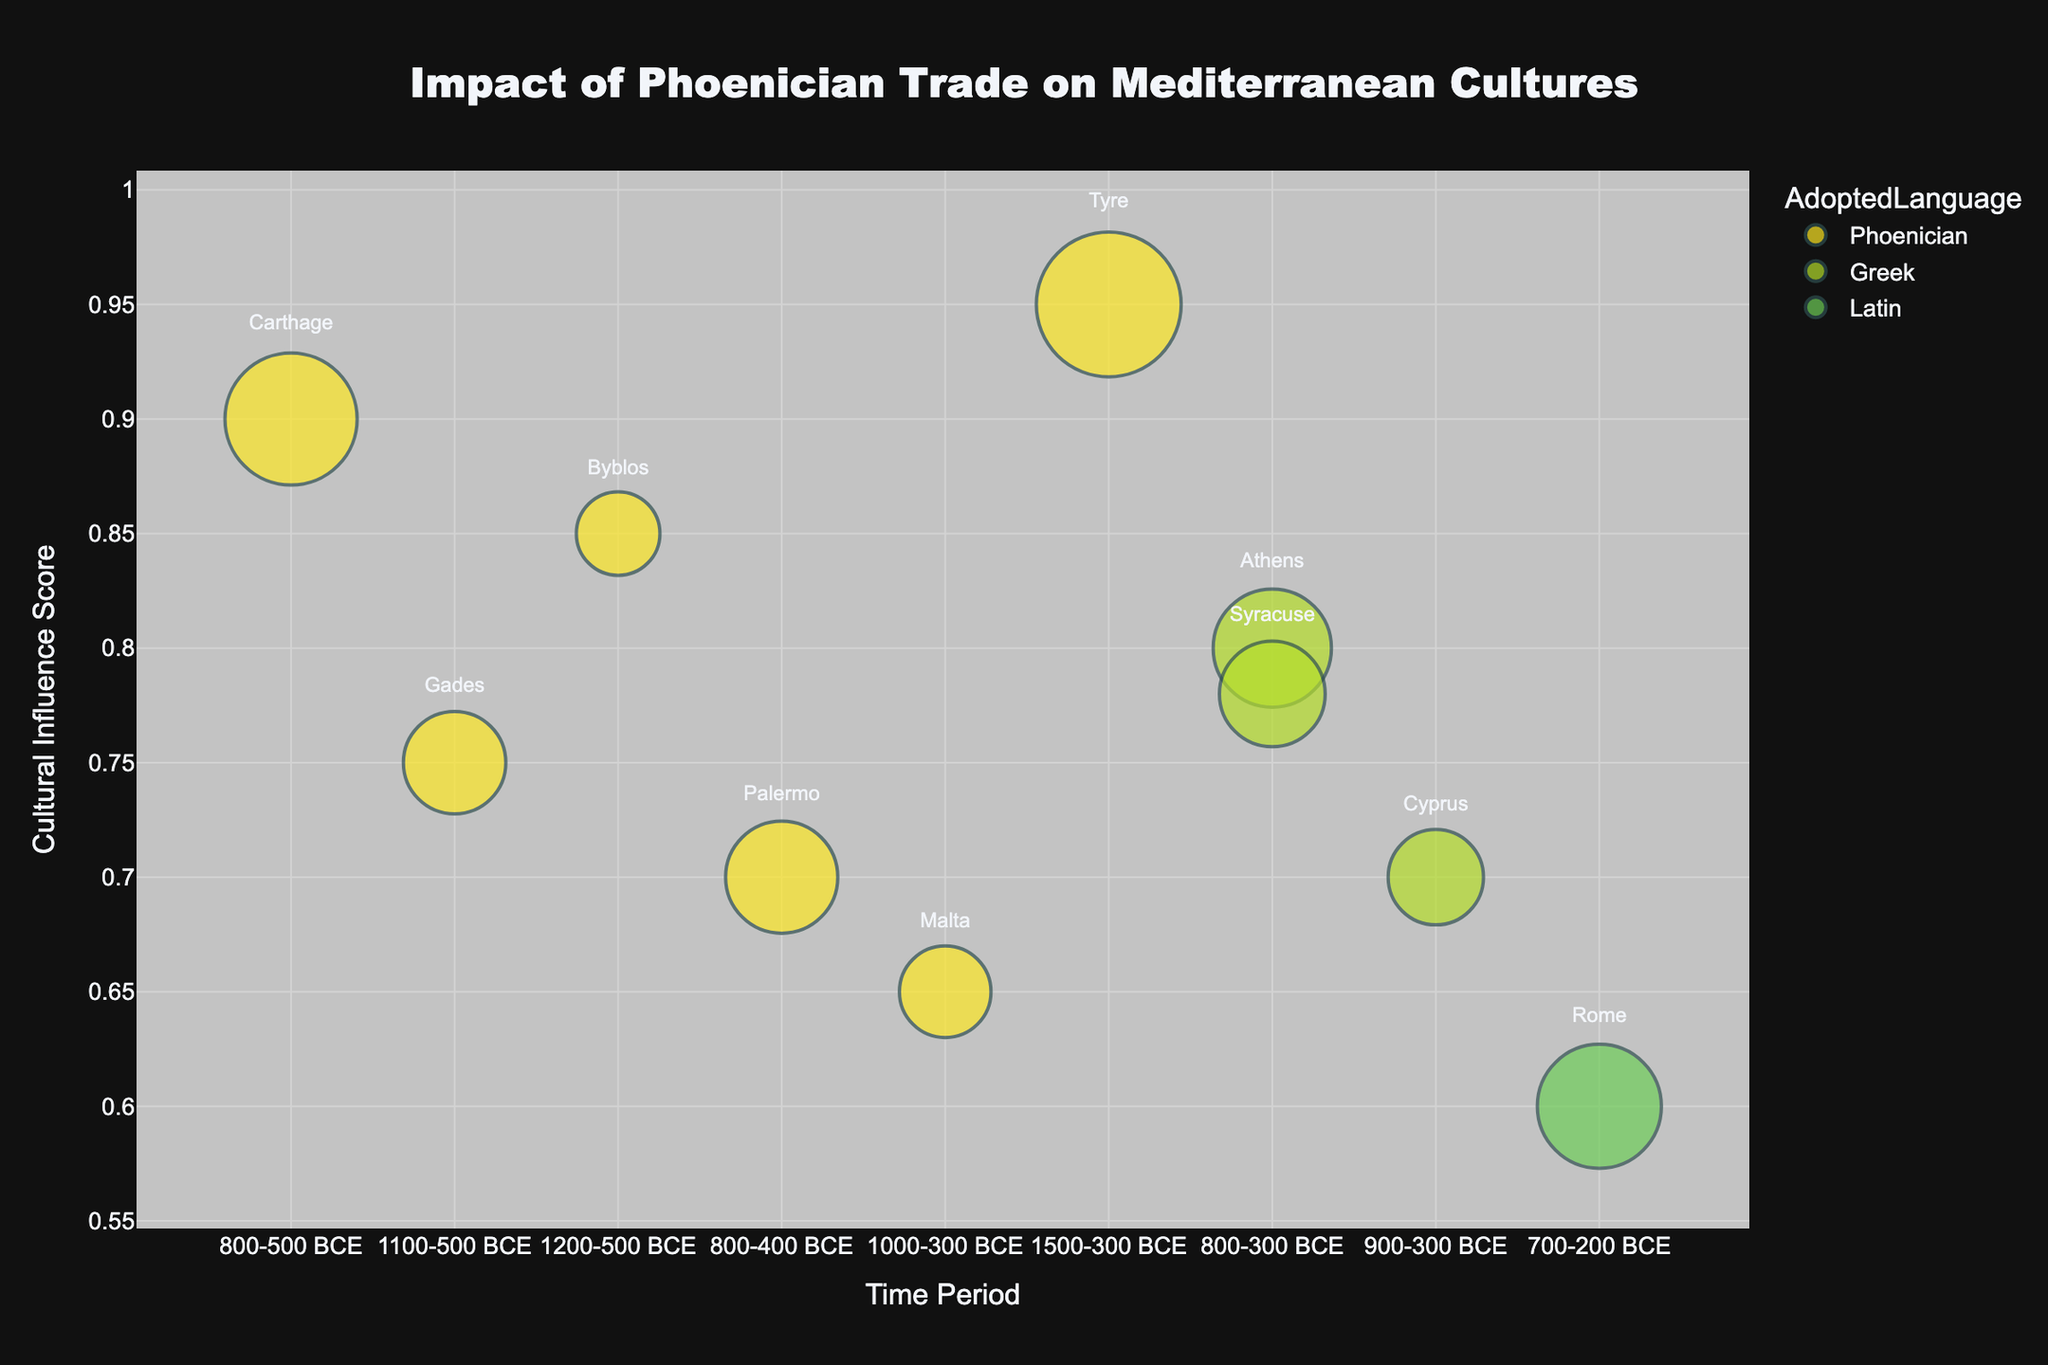What time period does the figure cover and what is the title of the plot? The title of the plot is "Impact of Phoenician Trade on Mediterranean Cultures," and the x-axis labeled "Time Period" ranges from 1500-300 BCE to 700-200 BCE.
Answer: "Impact of Phoenician Trade on Mediterranean Cultures"; 1500-200 BCE How many entities adopted the Phoenician language according to the chart? Examining the colors representing Phoenician, we count the entities: Carthage, Gades, Byblos, Palermo, Malta, and Tyre, making a total of six.
Answer: Six Which entity has the highest influence score and what is its trade volume? The entity with the highest position on the y-axis (Influence Score) is Tyre, with an Influence score of 0.95 and a Trade Volume of 300.
Answer: Tyre; 300 What is the average trade volume of entities that adopted Greek? The trade volumes for Greek-adopting entities are Athens (200), Cyprus (130), and Syracuse (160). Calculating the average: (200 + 130 + 160) / 3 = 490 / 3 ≈ 163.3.
Answer: ≈ 163.3 How do the influence scores of Carthage and Rome compare? Carthage has an Influence Score of 0.9 and Rome has an Influence Score of 0.6. Carthage's score is higher.
Answer: Carthage is higher Which entity has the smallest bubble (lowest trade volume) and what is its influence score? The smallest bubbles correspond to Byblos (trade volume 100) which also has an Influence Score of 0.85.
Answer: Byblos; 0.85 Are there any entities that adopted the Phoenician language but have an Influence Score lower than 0.7? If so, name them. From examining the bubbles, Malta has a Phoenician adoption and an Influence Score of 0.65, making it the only one that meets this condition.
Answer: Malta Which language has the most entities attributed to it? By counting the color-coded bubbles, Phoenician has the most entities with six, while Greek has three, and Latin has one.
Answer: Phoenician What is the time period range for all entities present on the chart? The earliest start time is 1500 BCE (Tyre), and the latest end time is 200 BCE (Rome).
Answer: 1500-200 BCE Which Greek-adopting entity has the highest influence score and what rank does it have among all entities? Syracuse has the highest influence score among the Greek adopters with a value of 0.78, positioning it below Carthage, Gades, Byblos, and Tyre but above Palermo, Malta, Cyprus, Athens, and Rome.
Answer: Syracuse; 5th 